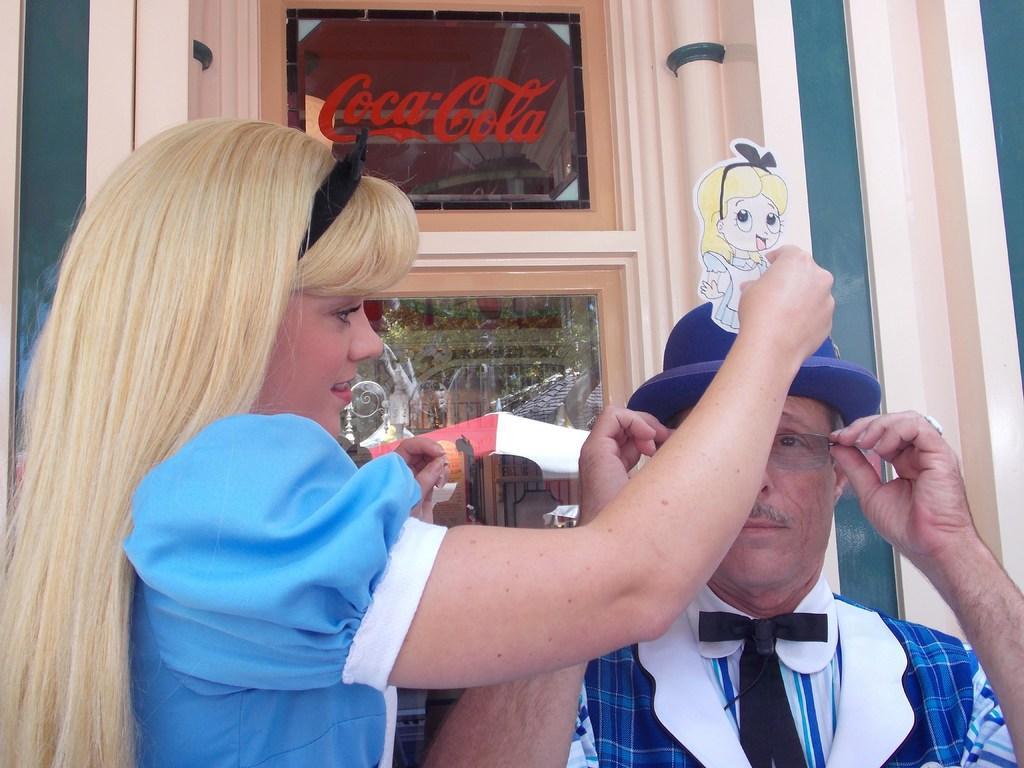How would you summarize this image in a sentence or two? In this image we can see a woman holding the woman sticker. We can also see a man wearing the glasses and also the hat. In the background we can see the glass window and we can also see the red color text on the window. 